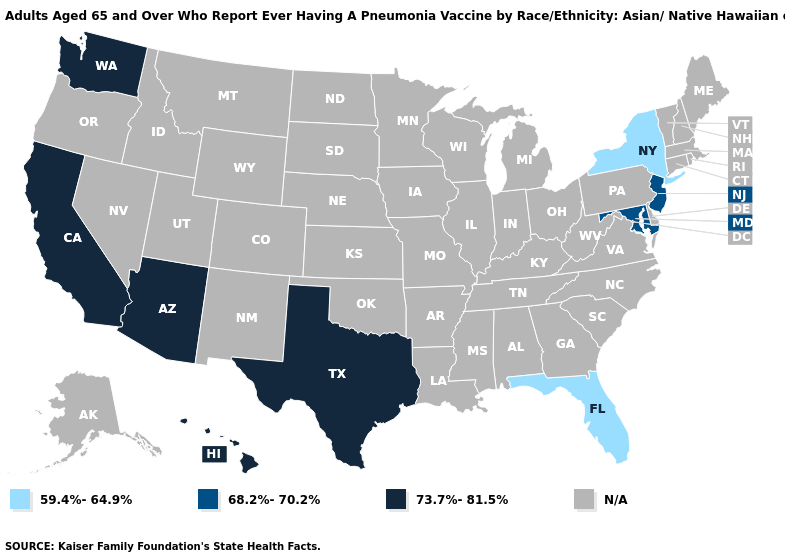How many symbols are there in the legend?
Give a very brief answer. 4. Among the states that border Oklahoma , which have the lowest value?
Be succinct. Texas. What is the value of New Mexico?
Keep it brief. N/A. Does the map have missing data?
Write a very short answer. Yes. Does the map have missing data?
Be succinct. Yes. What is the highest value in the USA?
Give a very brief answer. 73.7%-81.5%. Which states have the highest value in the USA?
Write a very short answer. Arizona, California, Hawaii, Texas, Washington. Does Arizona have the lowest value in the USA?
Answer briefly. No. What is the value of Iowa?
Give a very brief answer. N/A. What is the highest value in the Northeast ?
Quick response, please. 68.2%-70.2%. What is the value of California?
Answer briefly. 73.7%-81.5%. Which states hav the highest value in the South?
Concise answer only. Texas. What is the value of Pennsylvania?
Keep it brief. N/A. 